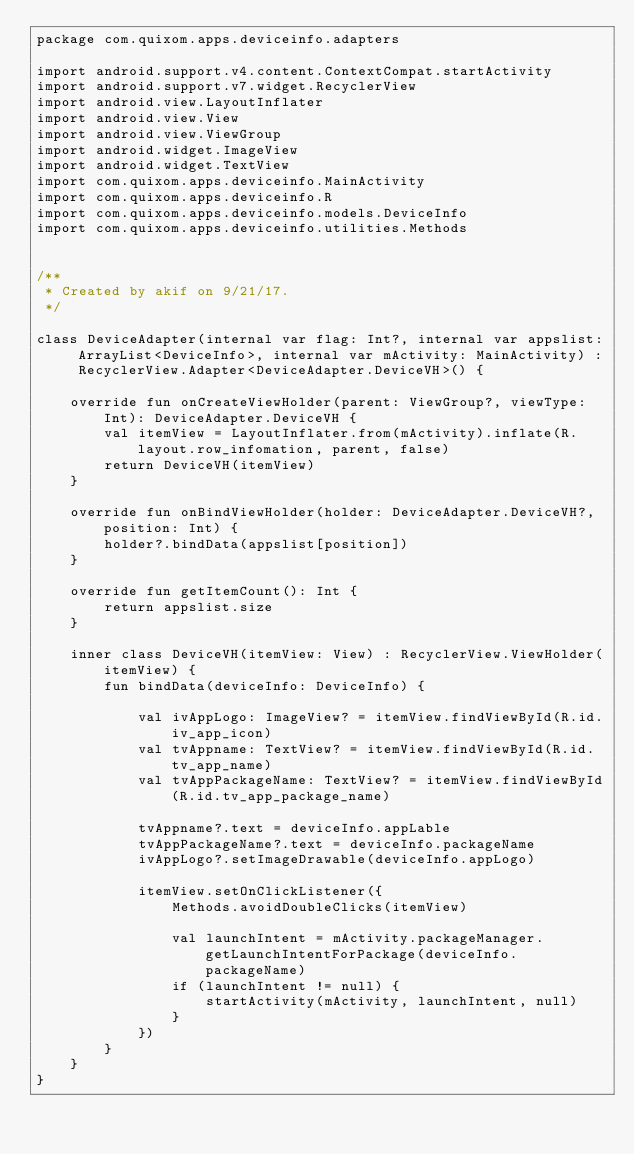Convert code to text. <code><loc_0><loc_0><loc_500><loc_500><_Kotlin_>package com.quixom.apps.deviceinfo.adapters

import android.support.v4.content.ContextCompat.startActivity
import android.support.v7.widget.RecyclerView
import android.view.LayoutInflater
import android.view.View
import android.view.ViewGroup
import android.widget.ImageView
import android.widget.TextView
import com.quixom.apps.deviceinfo.MainActivity
import com.quixom.apps.deviceinfo.R
import com.quixom.apps.deviceinfo.models.DeviceInfo
import com.quixom.apps.deviceinfo.utilities.Methods


/**
 * Created by akif on 9/21/17.
 */

class DeviceAdapter(internal var flag: Int?, internal var appslist: ArrayList<DeviceInfo>, internal var mActivity: MainActivity) : RecyclerView.Adapter<DeviceAdapter.DeviceVH>() {

    override fun onCreateViewHolder(parent: ViewGroup?, viewType: Int): DeviceAdapter.DeviceVH {
        val itemView = LayoutInflater.from(mActivity).inflate(R.layout.row_infomation, parent, false)
        return DeviceVH(itemView)
    }

    override fun onBindViewHolder(holder: DeviceAdapter.DeviceVH?, position: Int) {
        holder?.bindData(appslist[position])
    }

    override fun getItemCount(): Int {
        return appslist.size
    }

    inner class DeviceVH(itemView: View) : RecyclerView.ViewHolder(itemView) {
        fun bindData(deviceInfo: DeviceInfo) {

            val ivAppLogo: ImageView? = itemView.findViewById(R.id.iv_app_icon)
            val tvAppname: TextView? = itemView.findViewById(R.id.tv_app_name)
            val tvAppPackageName: TextView? = itemView.findViewById(R.id.tv_app_package_name)

            tvAppname?.text = deviceInfo.appLable
            tvAppPackageName?.text = deviceInfo.packageName
            ivAppLogo?.setImageDrawable(deviceInfo.appLogo)

            itemView.setOnClickListener({
                Methods.avoidDoubleClicks(itemView)

                val launchIntent = mActivity.packageManager.getLaunchIntentForPackage(deviceInfo.packageName)
                if (launchIntent != null) {
                    startActivity(mActivity, launchIntent, null)
                }
            })
        }
    }
}
</code> 